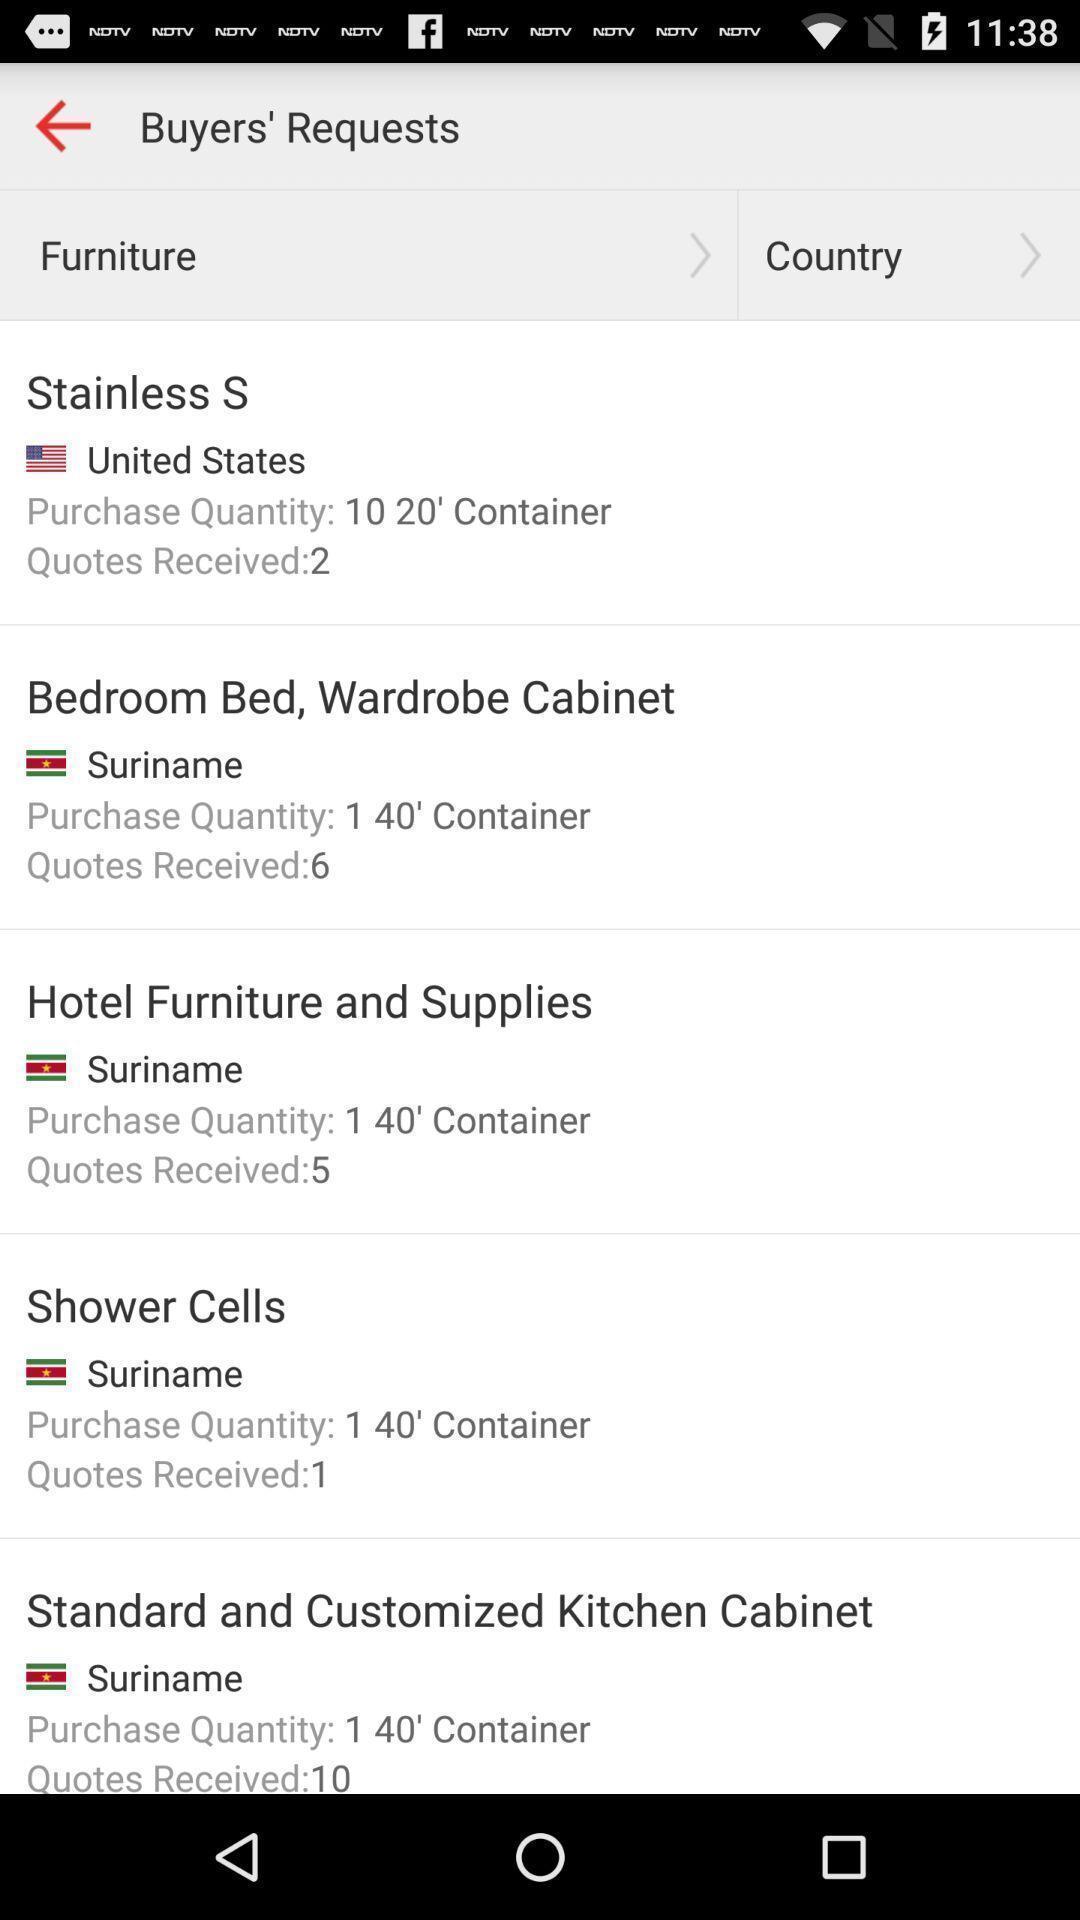Describe the visual elements of this screenshot. Page displaying with list of different furniture options. 